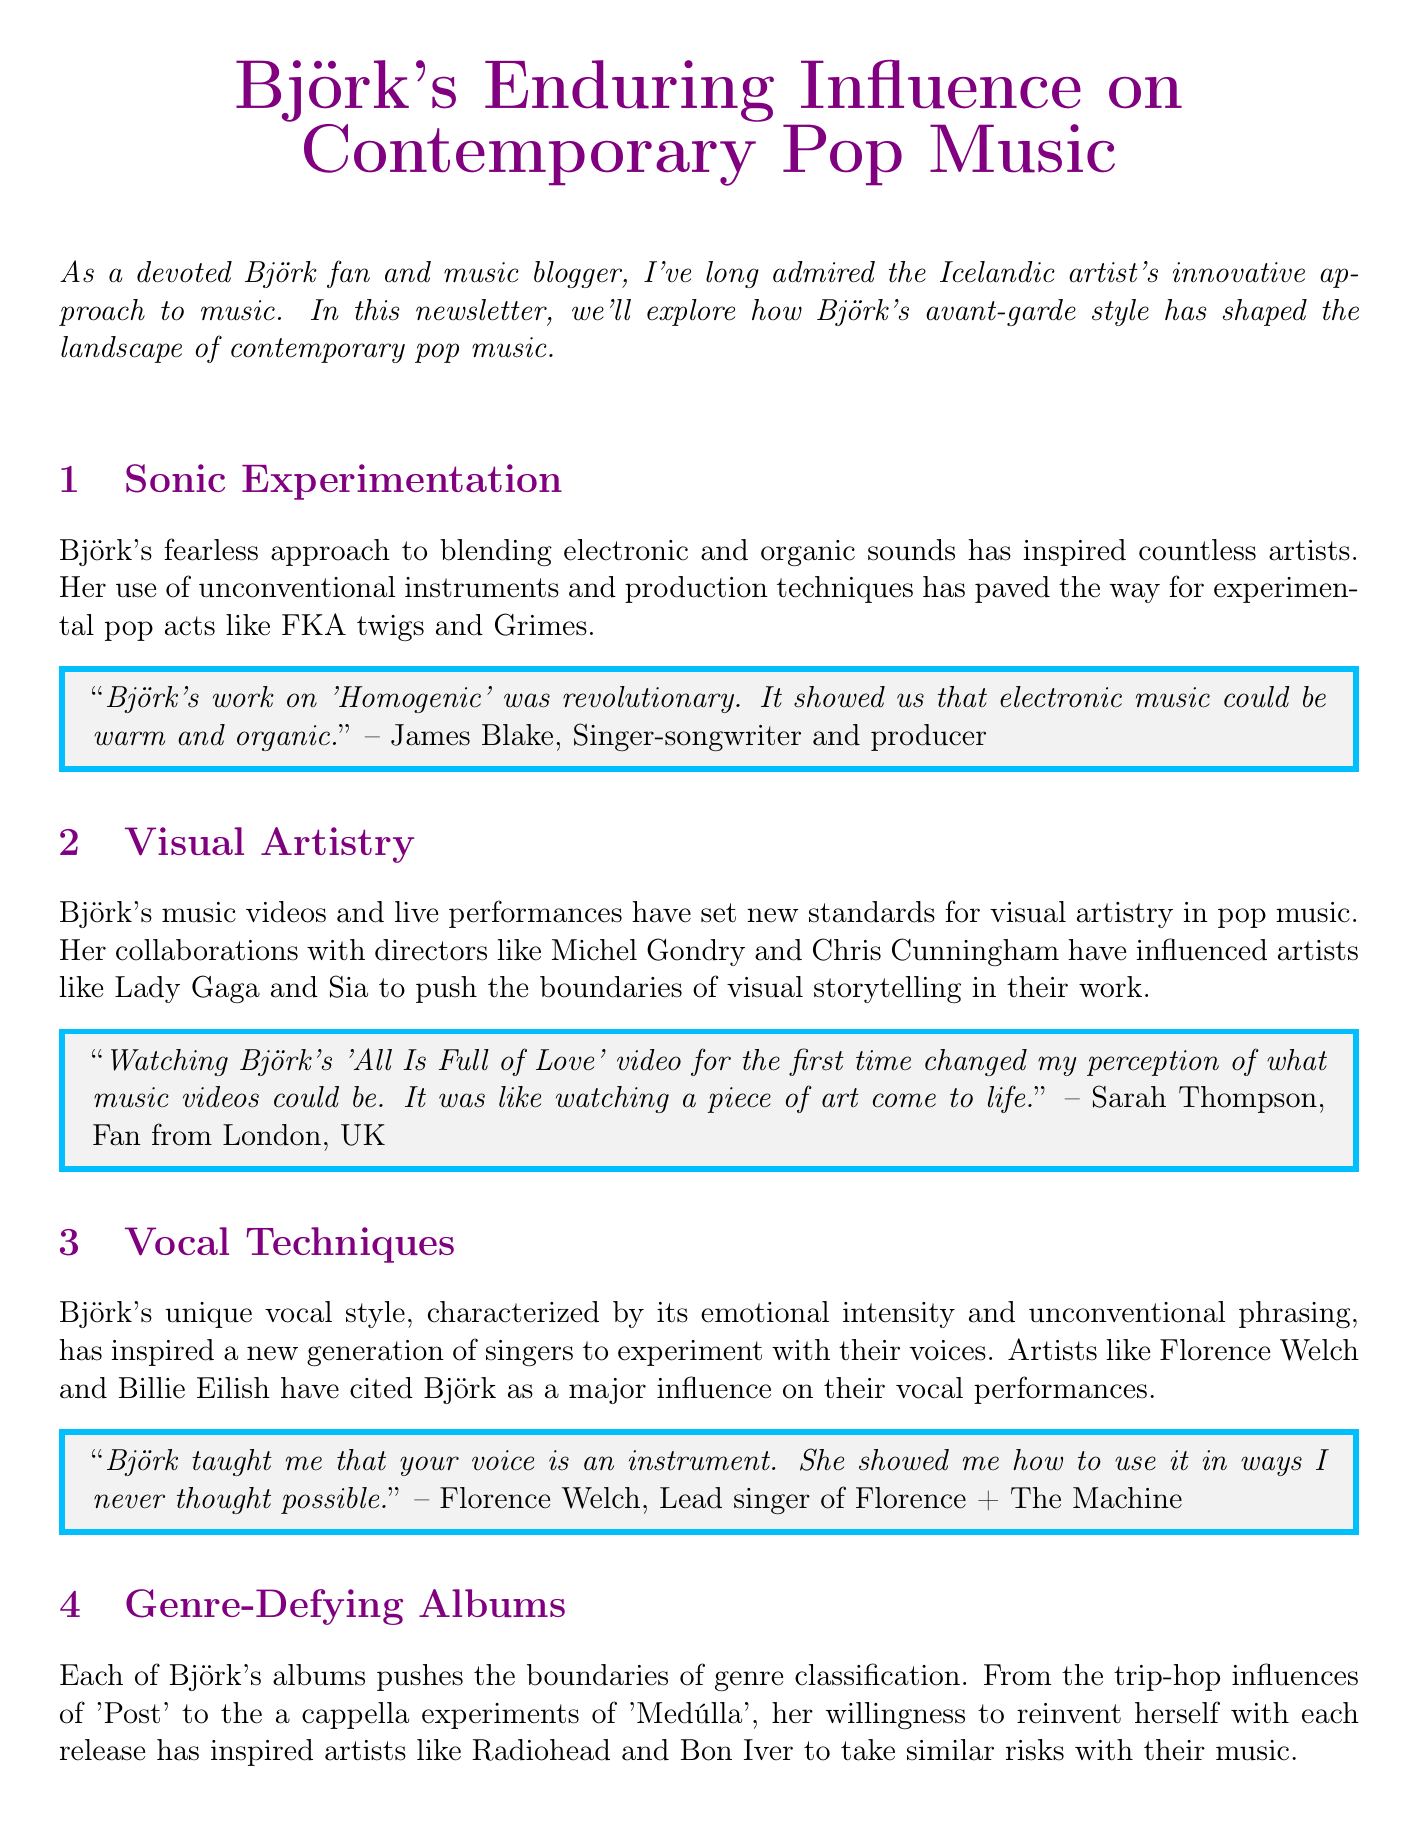What is the title of the newsletter? The title of the newsletter is stated at the beginning of the document.
Answer: Björk's Enduring Influence on Contemporary Pop Music Who is quoted regarding the sonic experimentation? The document cites a quote about sonic experimentation from James Blake, who is a singer-songwriter and producer.
Answer: James Blake Which artist is mentioned as influenced by Björk’s vocal techniques? The document lists several artists, among them is Florence Welch, who acknowledges Björk's influence on her vocal performance.
Answer: Florence Welch What technology did Björk use in her recent tours? The document discusses Björk's use of technology, specifically mentioning VR in her recent tours.
Answer: VR Which music video changed Sarah Thompson's perception of music videos? The document refers to the music video specifically associated with Sarah Thompson's testimony.
Answer: All Is Full of Love What genre influences were present in Björk's album 'Post'? The document highlights the influences that are found in Björk's album 'Post' under the section discussing genre-defying albums.
Answer: trip-hop Who is the fan testimonial from New York? The document includes a fan testimonial and states the name of the person from New York.
Answer: Michael Chen What is the profession of Rick Rubin? Rick Rubin's profession is prominently mentioned within his quote regarding genre-defying albums.
Answer: Record producer and former co-president of Columbia Records 